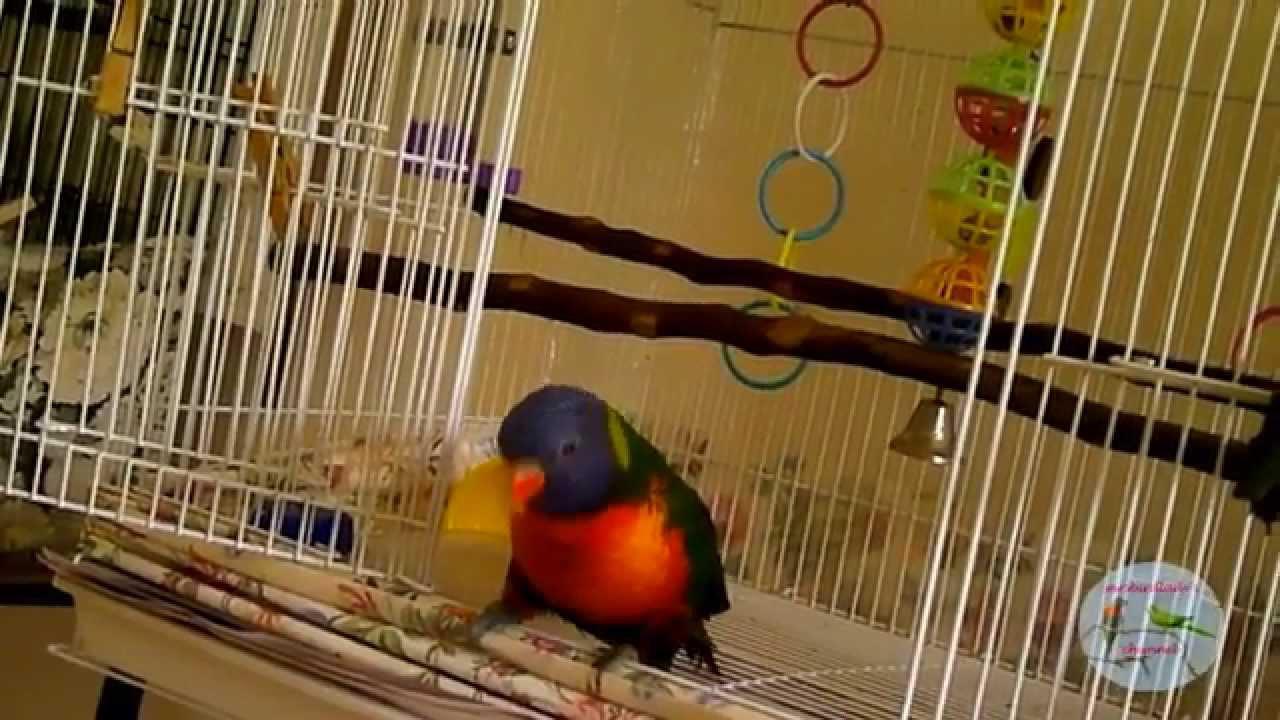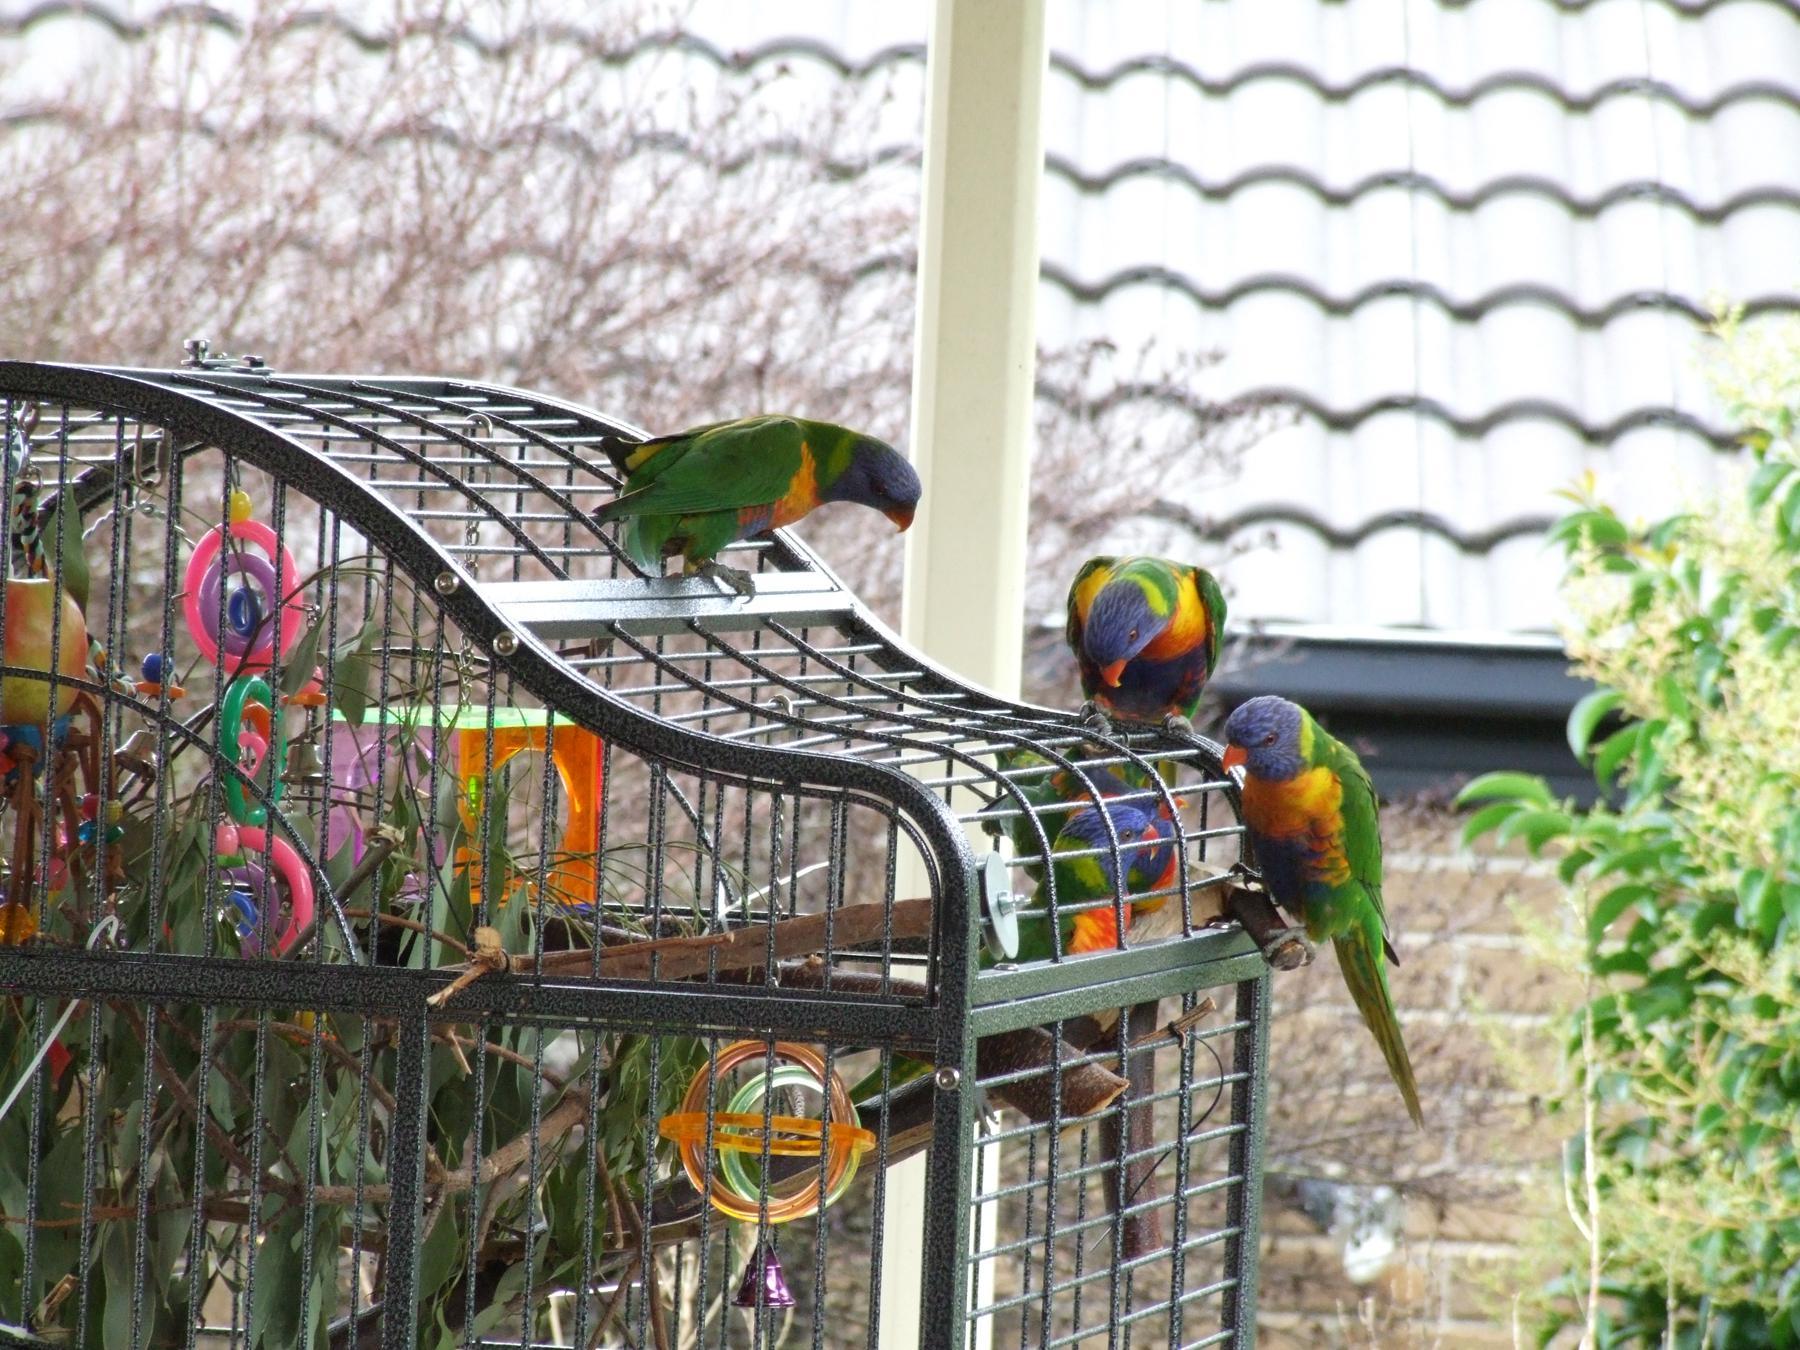The first image is the image on the left, the second image is the image on the right. Considering the images on both sides, is "A green bird is sitting in a cage in the image on the left." valid? Answer yes or no. No. The first image is the image on the left, the second image is the image on the right. For the images displayed, is the sentence "Each image features at least one bird and a wire bird cage." factually correct? Answer yes or no. Yes. 